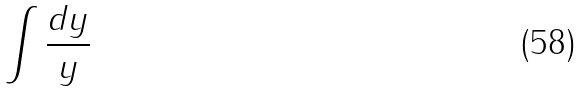Convert formula to latex. <formula><loc_0><loc_0><loc_500><loc_500>\int \frac { d y } { y }</formula> 